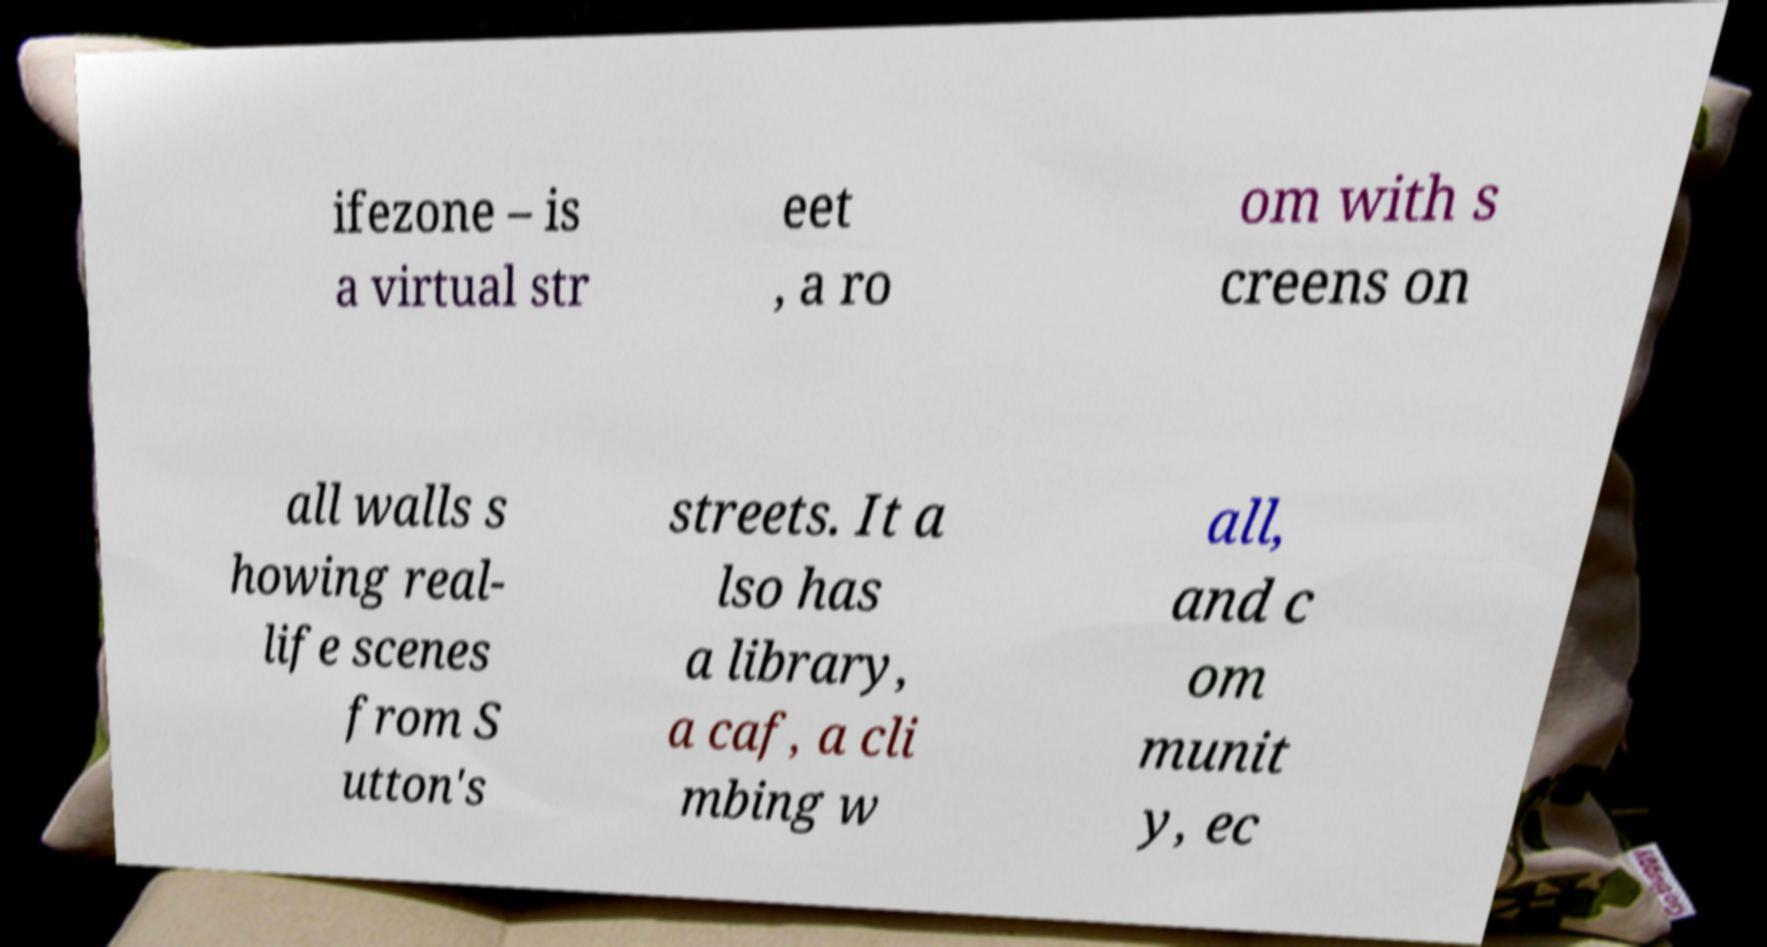Please identify and transcribe the text found in this image. ifezone – is a virtual str eet , a ro om with s creens on all walls s howing real- life scenes from S utton's streets. It a lso has a library, a caf, a cli mbing w all, and c om munit y, ec 